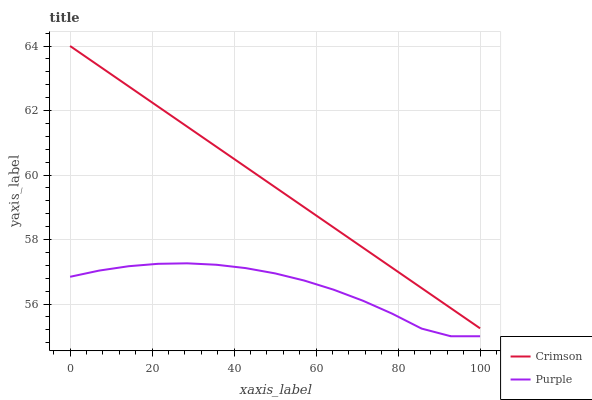Does Purple have the minimum area under the curve?
Answer yes or no. Yes. Does Crimson have the maximum area under the curve?
Answer yes or no. Yes. Does Purple have the maximum area under the curve?
Answer yes or no. No. Is Crimson the smoothest?
Answer yes or no. Yes. Is Purple the roughest?
Answer yes or no. Yes. Is Purple the smoothest?
Answer yes or no. No. Does Purple have the lowest value?
Answer yes or no. Yes. Does Crimson have the highest value?
Answer yes or no. Yes. Does Purple have the highest value?
Answer yes or no. No. Is Purple less than Crimson?
Answer yes or no. Yes. Is Crimson greater than Purple?
Answer yes or no. Yes. Does Purple intersect Crimson?
Answer yes or no. No. 